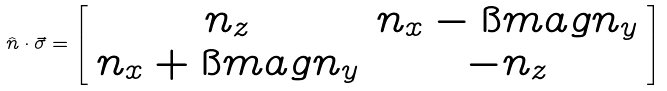<formula> <loc_0><loc_0><loc_500><loc_500>\hat { n } \cdot \vec { \sigma } = \left [ \begin{array} { c c } n _ { z } & n _ { x } - \i m a g n _ { y } \\ n _ { x } + \i m a g n _ { y } & - n _ { z } \end{array} \right ]</formula> 